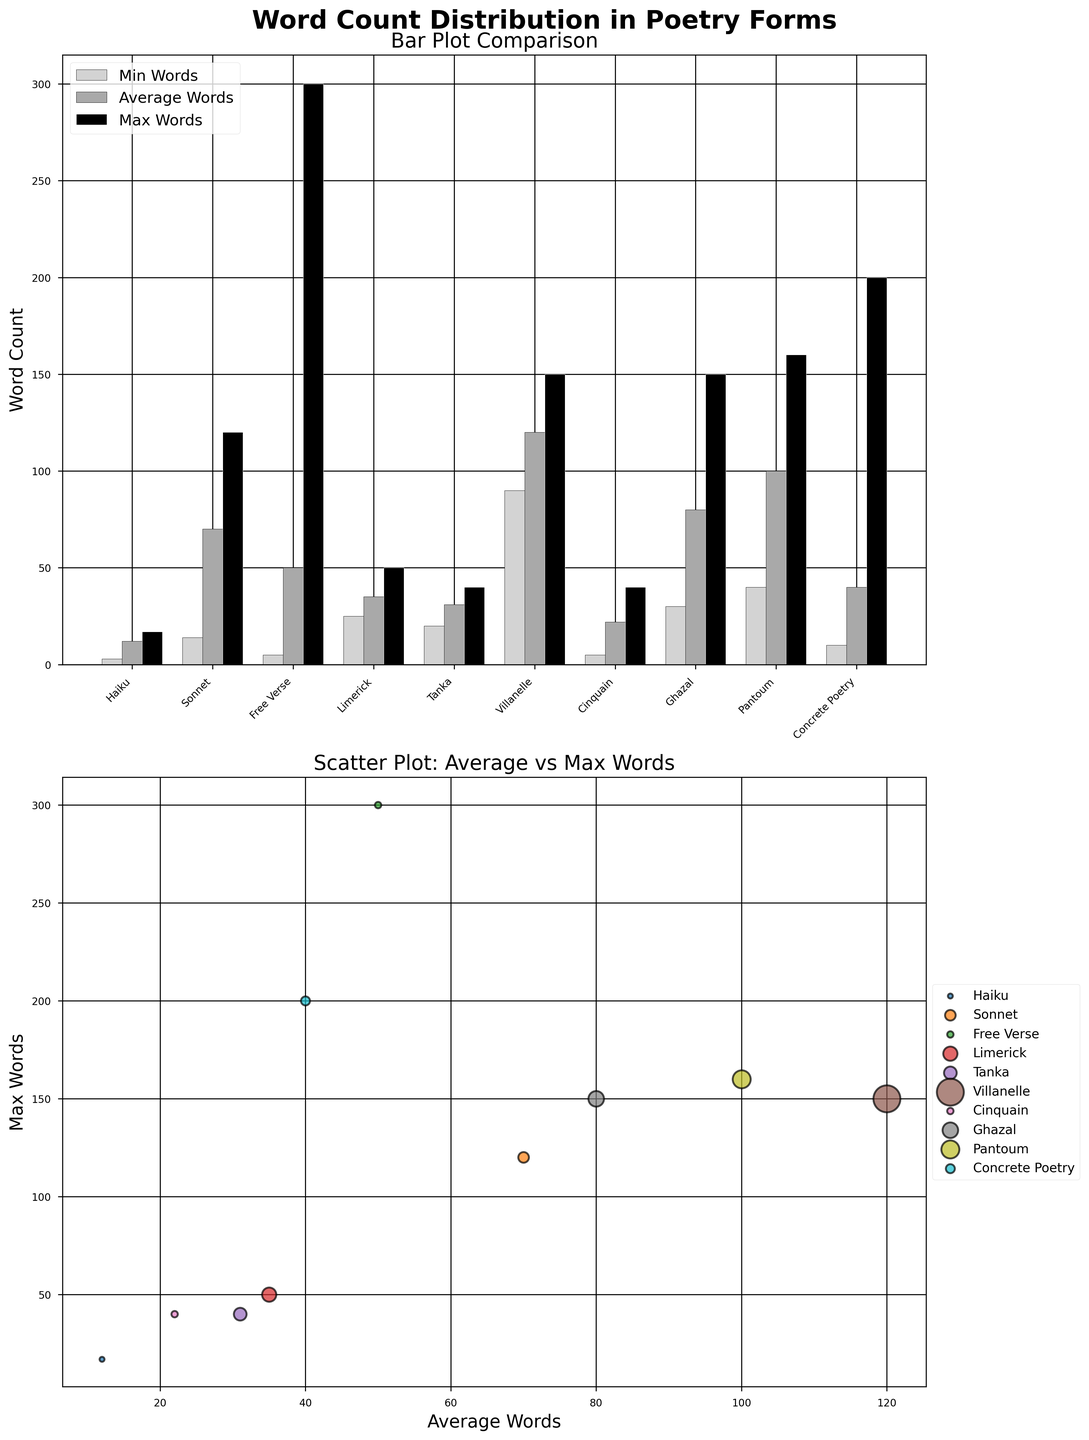What is the title of the scatter plot? The title of the scatter plot is written above the scatter plot itself. We see titles by looking at the top of the plots.
Answer: Scatter Plot: Average vs Max Words Which poetry form has the highest maximum word count in the bar plot? The highest maximum word count in the bar plot is labeled at the top of each bar. The tallest bar in the Max Words category corresponds to the form "Free Verse".
Answer: Free Verse What is the average word count for a Haiku compared to a Sonnet according to the bar plot? We find the average word counts for each form in the bar plot by looking at the middle bars. For Haiku, the average word count is directly above the "Haiku" label, and for Sonnet, it is above the "Sonnet" label.
Answer: 12 for Haiku, 70 for Sonnet How does the minimum word count of a Villanelle compare to that of a Ghazal? In the bar plot, the minimum word count is represented by the leftmost bars. By comparing the heights of the minimum word count bars for Villanelle and Ghazal, we see that Villanelle has a higher minimum word count.
Answer: Villanelle: 90, Ghazal: 30 Which poetry forms have the same maximum word count? The maximum word count bars show the maximum word counts. Checking the heights of these bars, we see that Ghazal and Pantoum both have maximum word counts of 150.
Answer: Ghazal and Pantoum On the scatter plot, what can we infer about the relationship between average words and maximum words for Villanelle? Villanelle appears on the scatter plot with average words on the x-axis and maximum words on the y-axis. Villanelle's position implies a high correlation, as it is placed towards the upper right.
Answer: High correlation between average and maximum words What are the range and diversity of word counts in Free Verse according to the bar plot? The range in the bar plot is seen through the heights of the three bars. For Free Verse, the minimum is 5, the average is 50, and the maximum is 300, indicating a wide range and diverse word count.
Answer: Range: 5-300, Diverse If we added the average word counts of Limerick and Tanka, what would the sum be? By locating the average word count bars for Limerick and Tanka, we see their heights (35 for Limerick and 31 for Tanka). Adding these gives us 35 + 31.
Answer: 66 Which poetry form has the smallest minimum word count, and what is the value? In the bar plot, looking at the shortest bar in the minimum word count category, we see that Haiku has the smallest minimum word count.
Answer: Haiku with 3 words In the scatter plot, which poetry form has the smallest average word count? The poetry form with the lowest position on the x-axis in the scatter plot has the smallest average word count. This is Haiku.
Answer: Haiku 